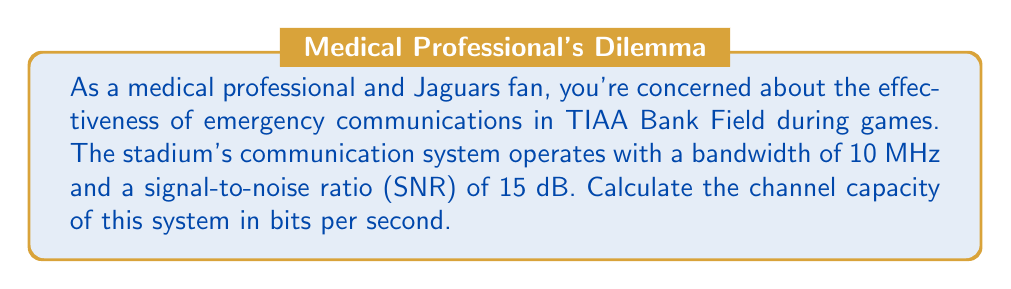Can you answer this question? To solve this problem, we'll use the Shannon-Hartley theorem, which gives the channel capacity for a communication system with Gaussian noise. The formula is:

$$C = B \log_2(1 + SNR)$$

Where:
$C$ = Channel capacity (bits per second)
$B$ = Bandwidth (Hz)
$SNR$ = Signal-to-noise ratio (linear scale)

Given:
- Bandwidth (B) = 10 MHz = $10 \times 10^6$ Hz
- SNR = 15 dB

Step 1: Convert SNR from decibels to linear scale
$SNR_{linear} = 10^{(SNR_{dB}/10)} = 10^{(15/10)} = 10^{1.5} \approx 31.6228$

Step 2: Apply the Shannon-Hartley theorem
$$\begin{align}
C &= B \log_2(1 + SNR) \\
&= (10 \times 10^6) \log_2(1 + 31.6228) \\
&= (10 \times 10^6) \log_2(32.6228)
\end{align}$$

Step 3: Calculate the result
$$\begin{align}
C &= (10 \times 10^6) \times 5.0279 \\
&= 50,279,000 \text{ bits per second} \\
&\approx 50.279 \text{ Mbps}
\end{align}$$

This channel capacity represents the maximum theoretical data rate that can be reliably transmitted through the stadium's communication system under the given conditions.
Answer: The channel capacity of the stadium's communication system is approximately 50.279 Mbps (megabits per second). 